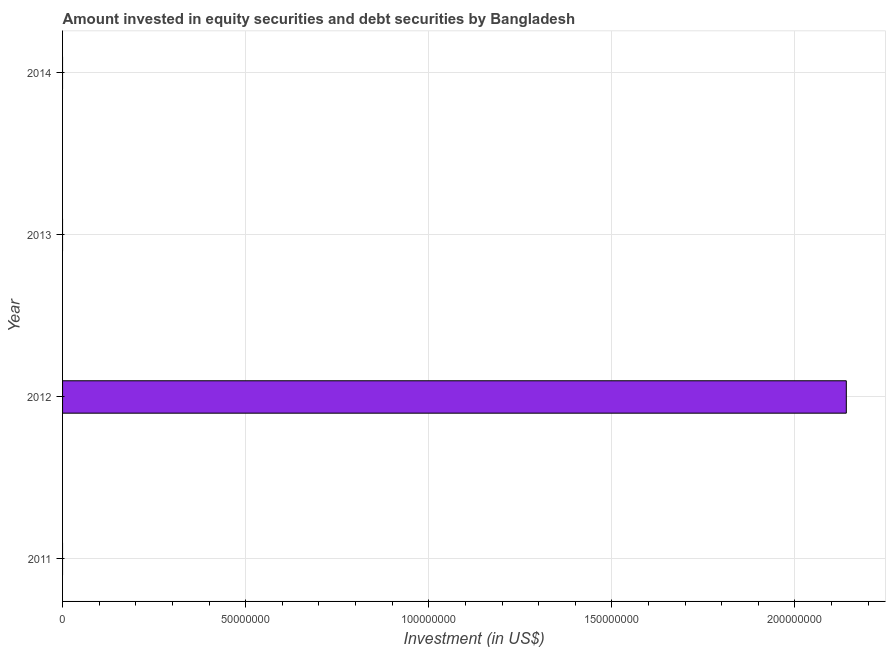Does the graph contain grids?
Give a very brief answer. Yes. What is the title of the graph?
Offer a terse response. Amount invested in equity securities and debt securities by Bangladesh. What is the label or title of the X-axis?
Keep it short and to the point. Investment (in US$). Across all years, what is the maximum portfolio investment?
Give a very brief answer. 2.14e+08. In which year was the portfolio investment maximum?
Keep it short and to the point. 2012. What is the sum of the portfolio investment?
Make the answer very short. 2.14e+08. What is the average portfolio investment per year?
Offer a very short reply. 5.35e+07. What is the difference between the highest and the lowest portfolio investment?
Provide a short and direct response. 2.14e+08. In how many years, is the portfolio investment greater than the average portfolio investment taken over all years?
Ensure brevity in your answer.  1. How many bars are there?
Ensure brevity in your answer.  1. Are all the bars in the graph horizontal?
Keep it short and to the point. Yes. How many years are there in the graph?
Give a very brief answer. 4. What is the Investment (in US$) of 2011?
Ensure brevity in your answer.  0. What is the Investment (in US$) in 2012?
Keep it short and to the point. 2.14e+08. What is the Investment (in US$) in 2014?
Your response must be concise. 0. 